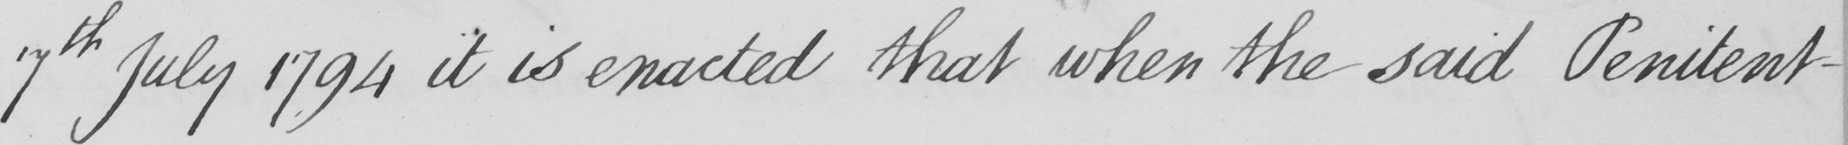What does this handwritten line say? 7th July 1794 it is enacted that when the said Penitent- 